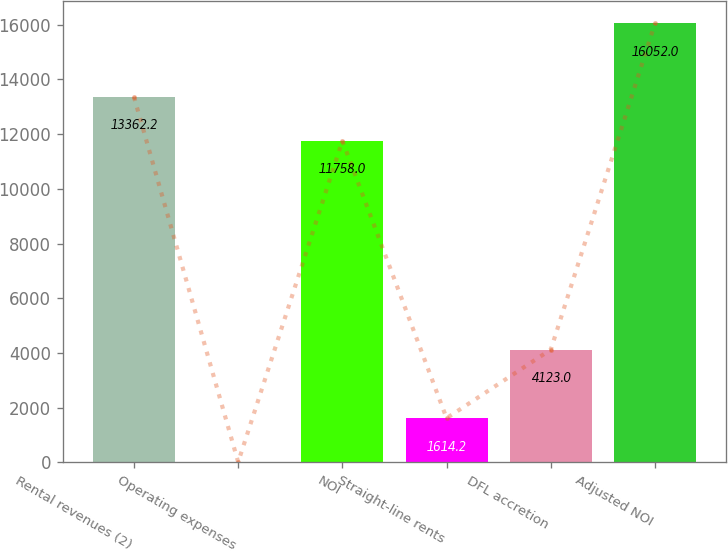Convert chart. <chart><loc_0><loc_0><loc_500><loc_500><bar_chart><fcel>Rental revenues (2)<fcel>Operating expenses<fcel>NOI<fcel>Straight-line rents<fcel>DFL accretion<fcel>Adjusted NOI<nl><fcel>13362.2<fcel>10<fcel>11758<fcel>1614.2<fcel>4123<fcel>16052<nl></chart> 